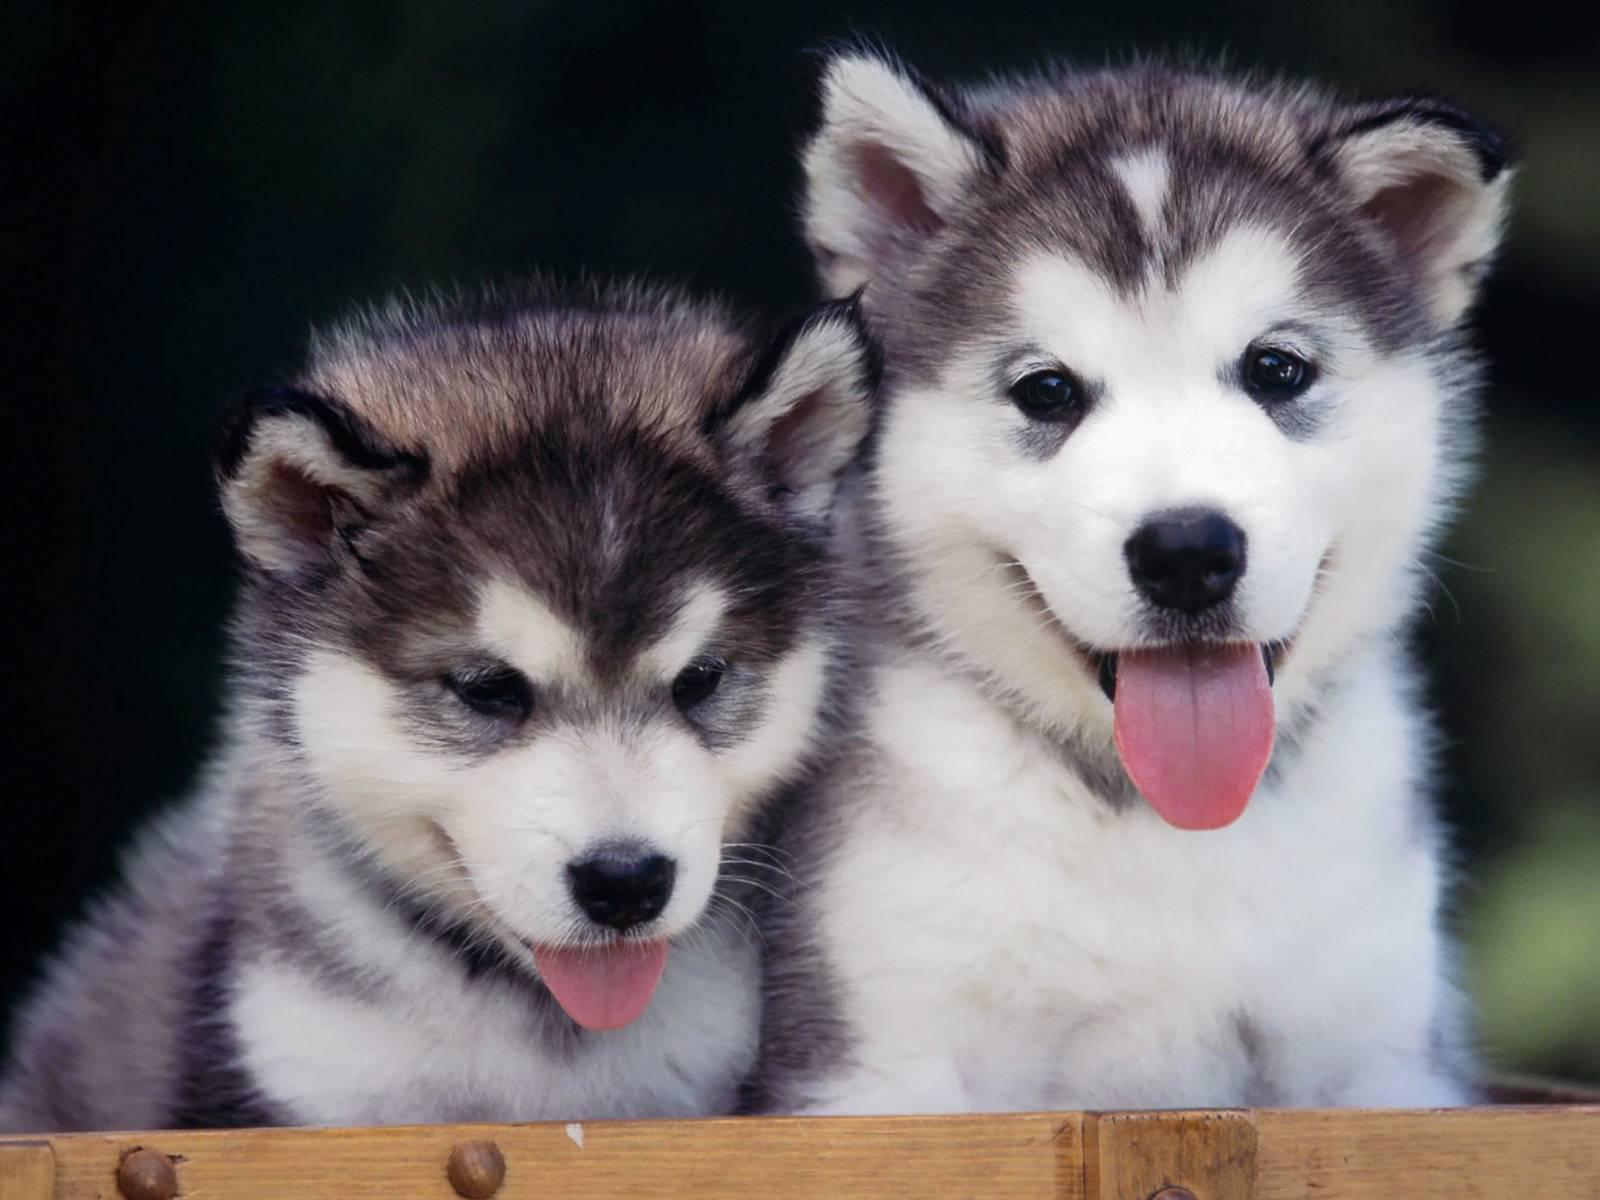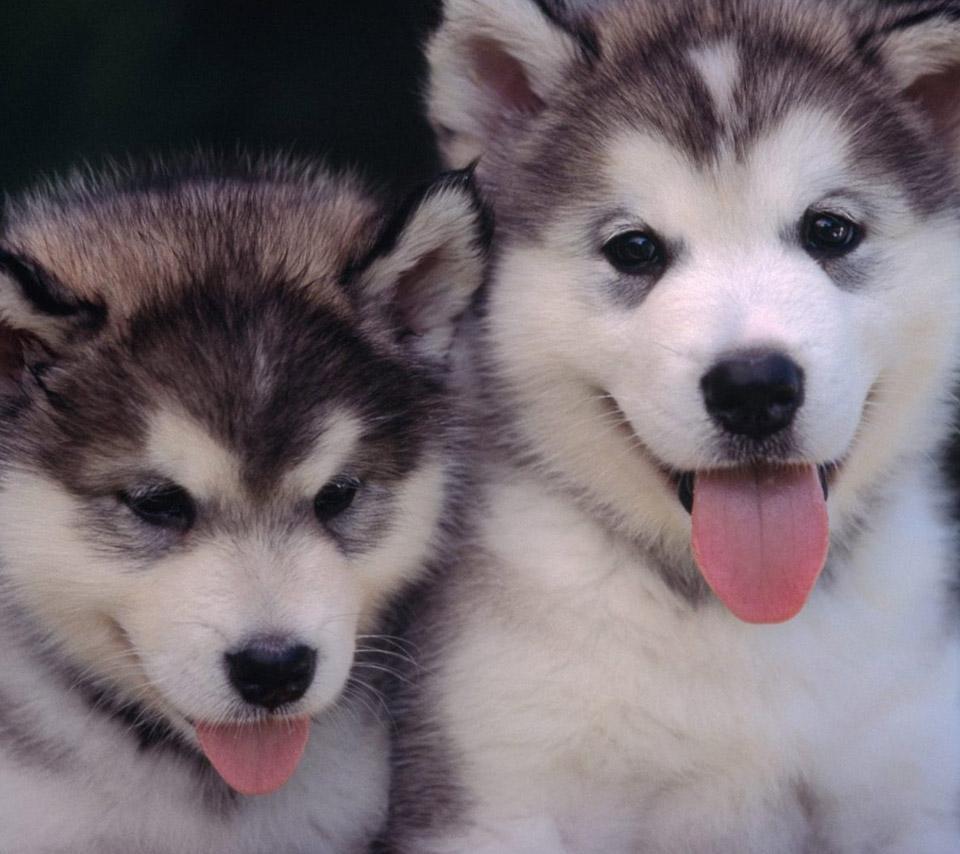The first image is the image on the left, the second image is the image on the right. Given the left and right images, does the statement "There are at most three puppies in the image pair." hold true? Answer yes or no. No. 